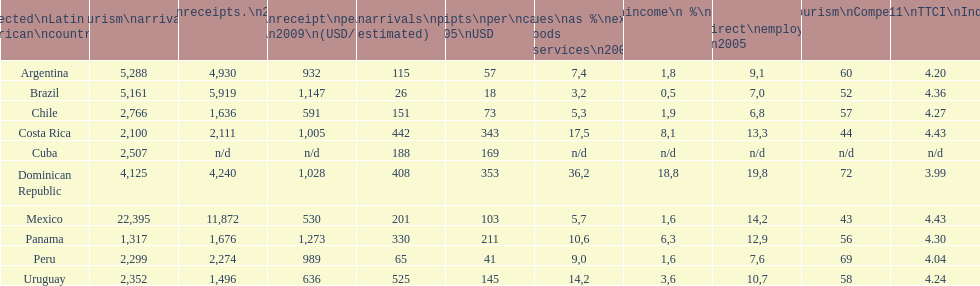Write the full table. {'header': ['Selected\\nLatin American\\ncountries', 'Internl.\\ntourism\\narrivals\\n2010\\n(x 1000)', 'Internl.\\ntourism\\nreceipts.\\n2010\\n(USD\\n(x1000)', 'Average\\nreceipt\\nper visitor\\n2009\\n(USD/turista)', 'Tourist\\narrivals\\nper\\n1000 inhab\\n(estimated) \\n2007', 'Receipts\\nper\\ncapita \\n2005\\nUSD', 'Revenues\\nas\xa0%\\nexports of\\ngoods and\\nservices\\n2003', 'Tourism\\nincome\\n\xa0%\\nGDP\\n2003', '% Direct and\\nindirect\\nemployment\\nin tourism\\n2005', 'World\\nranking\\nTourism\\nCompetitiv.\\nTTCI\\n2011', '2011\\nTTCI\\nIndex'], 'rows': [['Argentina', '5,288', '4,930', '932', '115', '57', '7,4', '1,8', '9,1', '60', '4.20'], ['Brazil', '5,161', '5,919', '1,147', '26', '18', '3,2', '0,5', '7,0', '52', '4.36'], ['Chile', '2,766', '1,636', '591', '151', '73', '5,3', '1,9', '6,8', '57', '4.27'], ['Costa Rica', '2,100', '2,111', '1,005', '442', '343', '17,5', '8,1', '13,3', '44', '4.43'], ['Cuba', '2,507', 'n/d', 'n/d', '188', '169', 'n/d', 'n/d', 'n/d', 'n/d', 'n/d'], ['Dominican Republic', '4,125', '4,240', '1,028', '408', '353', '36,2', '18,8', '19,8', '72', '3.99'], ['Mexico', '22,395', '11,872', '530', '201', '103', '5,7', '1,6', '14,2', '43', '4.43'], ['Panama', '1,317', '1,676', '1,273', '330', '211', '10,6', '6,3', '12,9', '56', '4.30'], ['Peru', '2,299', '2,274', '989', '65', '41', '9,0', '1,6', '7,6', '69', '4.04'], ['Uruguay', '2,352', '1,496', '636', '525', '145', '14,2', '3,6', '10,7', '58', '4.24']]} How many dollars on average did brazil receive per tourist in 2009? 1,147. 